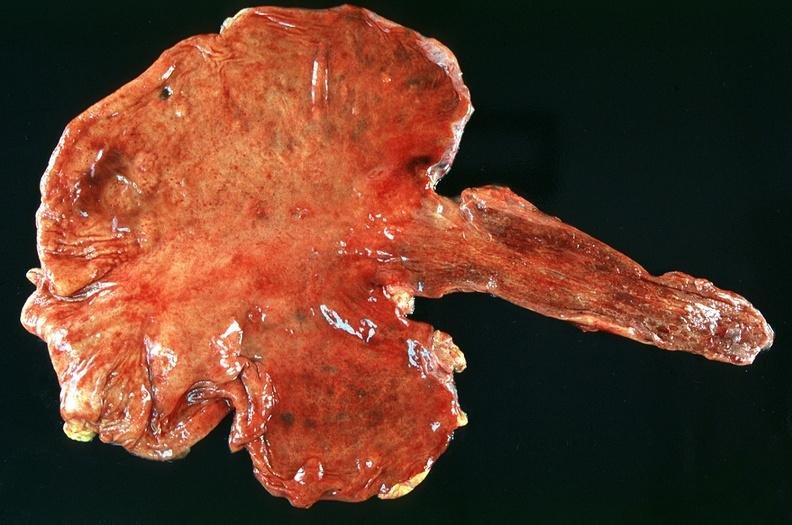does malignant adenoma show stomach, ulcerations and hemorrhages nosogastric tube?
Answer the question using a single word or phrase. No 